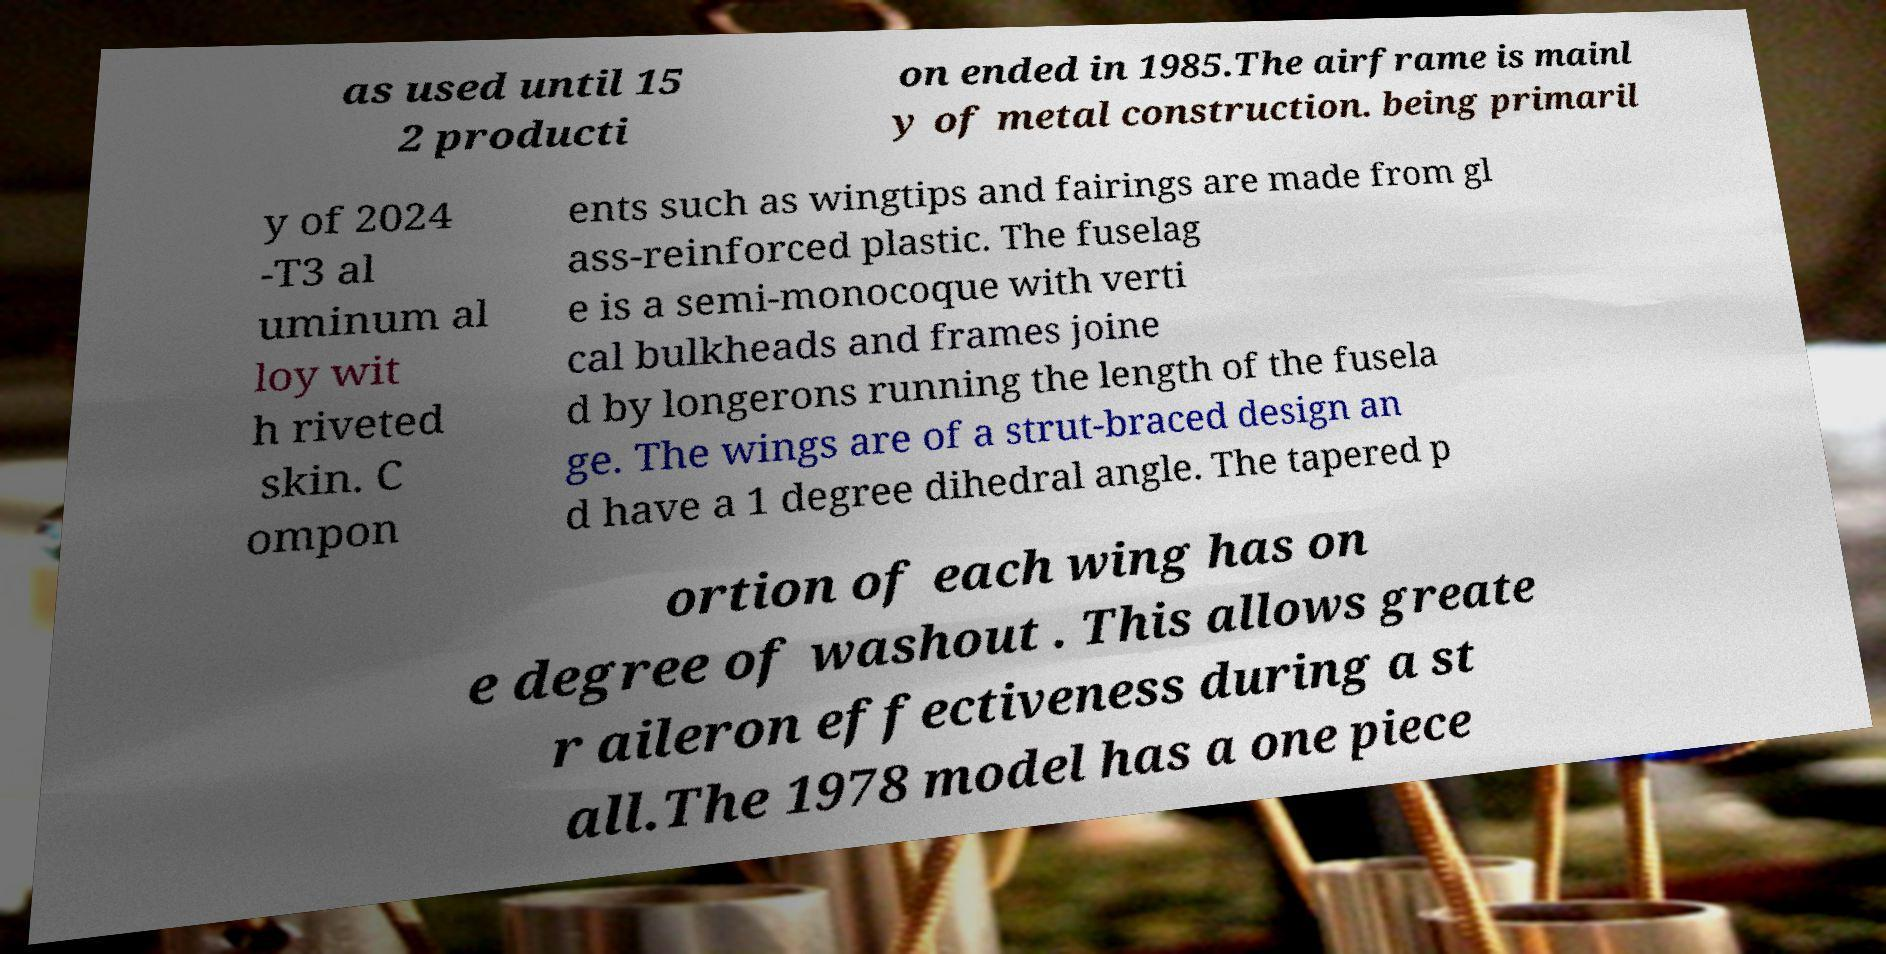There's text embedded in this image that I need extracted. Can you transcribe it verbatim? as used until 15 2 producti on ended in 1985.The airframe is mainl y of metal construction. being primaril y of 2024 -T3 al uminum al loy wit h riveted skin. C ompon ents such as wingtips and fairings are made from gl ass-reinforced plastic. The fuselag e is a semi-monocoque with verti cal bulkheads and frames joine d by longerons running the length of the fusela ge. The wings are of a strut-braced design an d have a 1 degree dihedral angle. The tapered p ortion of each wing has on e degree of washout . This allows greate r aileron effectiveness during a st all.The 1978 model has a one piece 